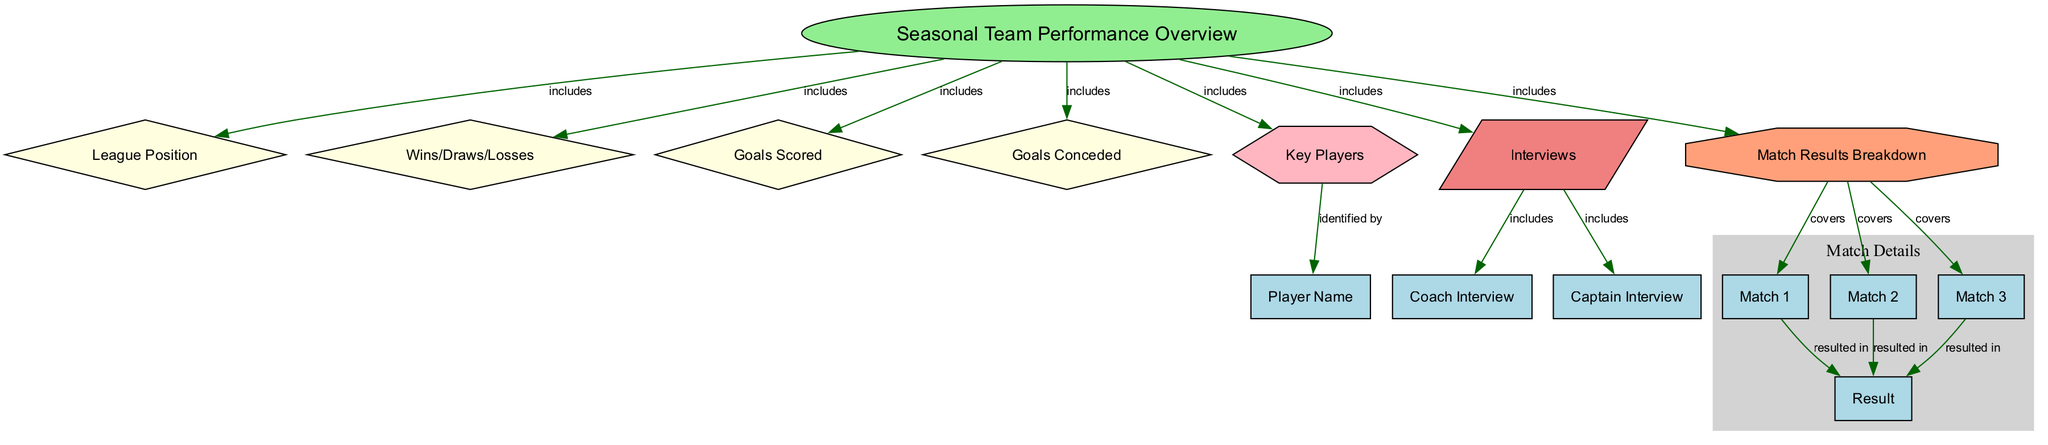What is the main focus of the diagram? The main focus of the diagram is encapsulated in the node labeled "Seasonal Team Performance Overview," which includes various details such as league position, wins, draws, losses, goals scored, goals conceded, key players, interviews, and match results breakdown.
Answer: Seasonal Team Performance Overview How many matches are included in the match results breakdown? The match results breakdown covers three matches as indicated by the nodes labeled "Match 1," "Match 2," and "Match 3."
Answer: 3 What type of players are identified under the key players section? Under the key players section, individual players are identified by their names, which are detailed in the node labeled "Player Name."
Answer: Players What is the relationship between the team performance overview and interviews? The team performance overview includes interviews as indicated by the edge connecting "team performance overview" and "interviews."
Answer: includes What kind of information is provided in the coach interview node? The coach interview node is a part of the interviews section and provides insights related to the team's performance from the coach's perspective.
Answer: insights Which node indicates the results of the matches? The nodes labeled "result" connected to matches indicate the outcomes of each match in the match results breakdown.
Answer: result How does the team performance overview relate to league position? The relationship is shown by the edge label "includes," pointing out that league position is a part of or included in the overall team performance overview.
Answer: includes What format is used to display the teams’ wins, draws, and losses? The wins, draws, and losses are displayed as a single node labeled "Wins/Draws/Losses" within the team performance overview section.
Answer: Wins/Draws/Losses Which type of node is used to represent key players? The key players are represented by a hexagon-shaped node in the diagram, emphasizing their importance within the context of the team performance overview.
Answer: hexagon 